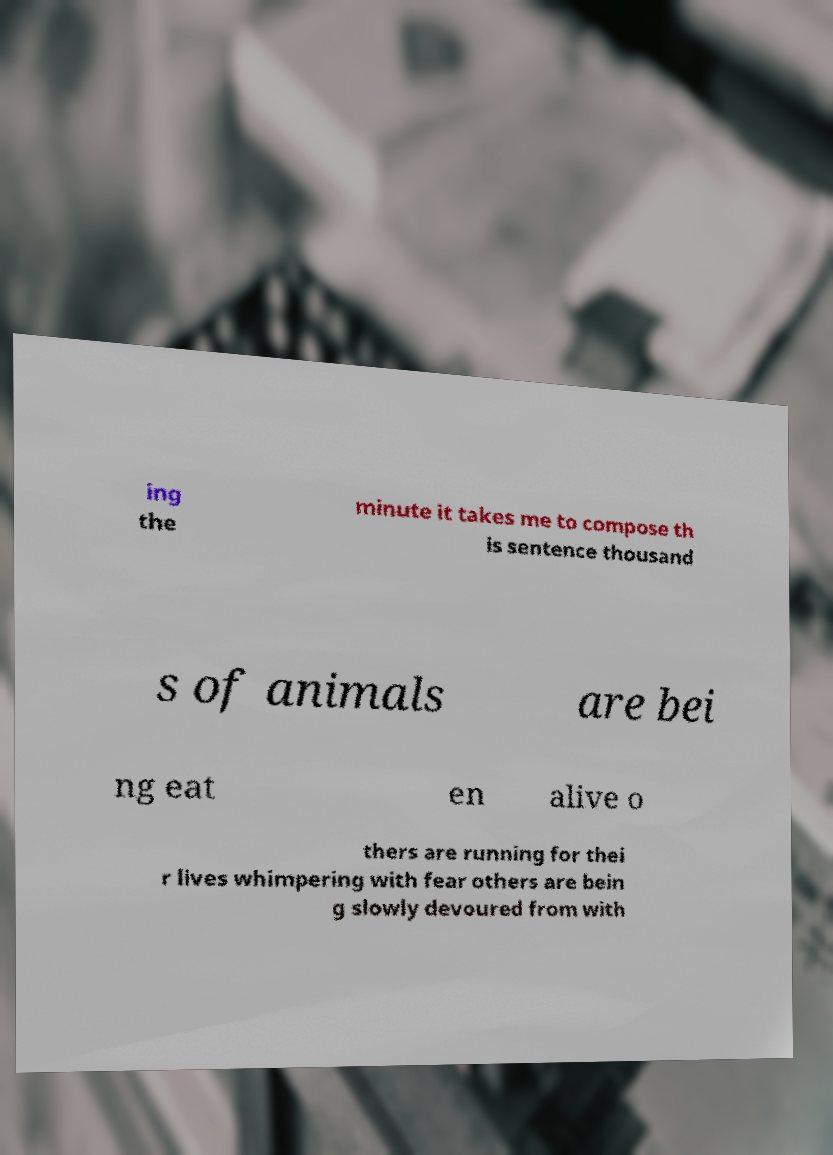Can you read and provide the text displayed in the image?This photo seems to have some interesting text. Can you extract and type it out for me? ing the minute it takes me to compose th is sentence thousand s of animals are bei ng eat en alive o thers are running for thei r lives whimpering with fear others are bein g slowly devoured from with 